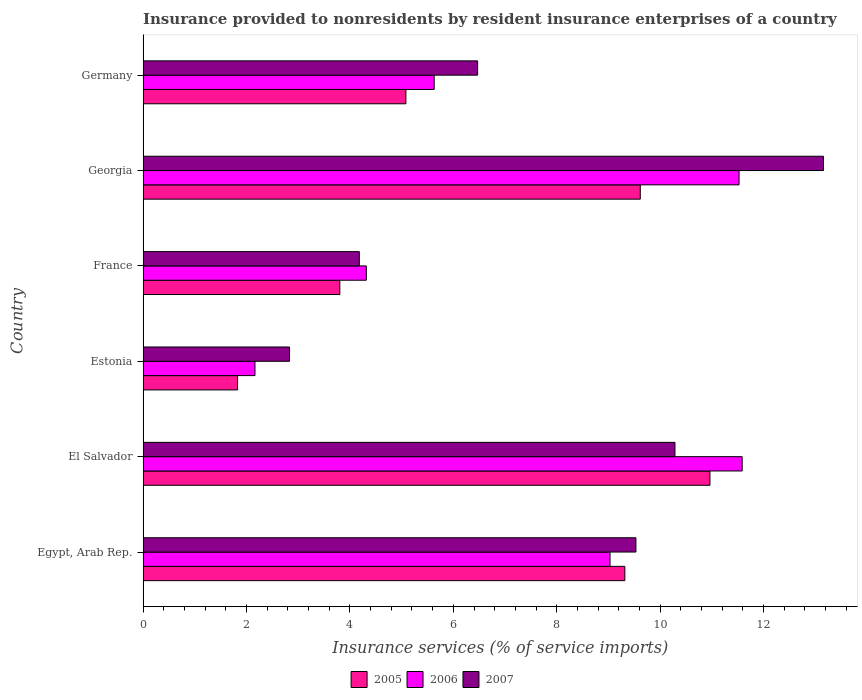Are the number of bars on each tick of the Y-axis equal?
Provide a short and direct response. Yes. How many bars are there on the 5th tick from the bottom?
Offer a terse response. 3. What is the label of the 6th group of bars from the top?
Provide a succinct answer. Egypt, Arab Rep. What is the insurance provided to nonresidents in 2005 in Germany?
Your answer should be compact. 5.08. Across all countries, what is the maximum insurance provided to nonresidents in 2006?
Offer a terse response. 11.59. Across all countries, what is the minimum insurance provided to nonresidents in 2007?
Ensure brevity in your answer.  2.83. In which country was the insurance provided to nonresidents in 2005 maximum?
Your answer should be very brief. El Salvador. In which country was the insurance provided to nonresidents in 2007 minimum?
Your response must be concise. Estonia. What is the total insurance provided to nonresidents in 2005 in the graph?
Provide a short and direct response. 40.61. What is the difference between the insurance provided to nonresidents in 2006 in Egypt, Arab Rep. and that in France?
Keep it short and to the point. 4.71. What is the difference between the insurance provided to nonresidents in 2005 in France and the insurance provided to nonresidents in 2006 in Georgia?
Provide a short and direct response. -7.72. What is the average insurance provided to nonresidents in 2005 per country?
Offer a terse response. 6.77. What is the difference between the insurance provided to nonresidents in 2005 and insurance provided to nonresidents in 2006 in Germany?
Offer a very short reply. -0.55. What is the ratio of the insurance provided to nonresidents in 2006 in Georgia to that in Germany?
Offer a very short reply. 2.05. Is the insurance provided to nonresidents in 2007 in Egypt, Arab Rep. less than that in France?
Offer a very short reply. No. Is the difference between the insurance provided to nonresidents in 2005 in El Salvador and France greater than the difference between the insurance provided to nonresidents in 2006 in El Salvador and France?
Make the answer very short. No. What is the difference between the highest and the second highest insurance provided to nonresidents in 2005?
Offer a terse response. 1.35. What is the difference between the highest and the lowest insurance provided to nonresidents in 2005?
Your answer should be very brief. 9.13. In how many countries, is the insurance provided to nonresidents in 2006 greater than the average insurance provided to nonresidents in 2006 taken over all countries?
Make the answer very short. 3. What does the 2nd bar from the top in Estonia represents?
Your response must be concise. 2006. What does the 1st bar from the bottom in Egypt, Arab Rep. represents?
Give a very brief answer. 2005. How many countries are there in the graph?
Provide a succinct answer. 6. What is the difference between two consecutive major ticks on the X-axis?
Give a very brief answer. 2. Does the graph contain any zero values?
Provide a short and direct response. No. How are the legend labels stacked?
Provide a succinct answer. Horizontal. What is the title of the graph?
Give a very brief answer. Insurance provided to nonresidents by resident insurance enterprises of a country. Does "2009" appear as one of the legend labels in the graph?
Offer a terse response. No. What is the label or title of the X-axis?
Give a very brief answer. Insurance services (% of service imports). What is the label or title of the Y-axis?
Your answer should be compact. Country. What is the Insurance services (% of service imports) of 2005 in Egypt, Arab Rep.?
Your answer should be compact. 9.32. What is the Insurance services (% of service imports) of 2006 in Egypt, Arab Rep.?
Offer a terse response. 9.03. What is the Insurance services (% of service imports) of 2007 in Egypt, Arab Rep.?
Your answer should be very brief. 9.53. What is the Insurance services (% of service imports) of 2005 in El Salvador?
Keep it short and to the point. 10.96. What is the Insurance services (% of service imports) in 2006 in El Salvador?
Ensure brevity in your answer.  11.59. What is the Insurance services (% of service imports) in 2007 in El Salvador?
Provide a succinct answer. 10.29. What is the Insurance services (% of service imports) of 2005 in Estonia?
Make the answer very short. 1.83. What is the Insurance services (% of service imports) in 2006 in Estonia?
Make the answer very short. 2.16. What is the Insurance services (% of service imports) of 2007 in Estonia?
Your answer should be very brief. 2.83. What is the Insurance services (% of service imports) of 2005 in France?
Your answer should be compact. 3.81. What is the Insurance services (% of service imports) in 2006 in France?
Make the answer very short. 4.32. What is the Insurance services (% of service imports) of 2007 in France?
Ensure brevity in your answer.  4.18. What is the Insurance services (% of service imports) in 2005 in Georgia?
Keep it short and to the point. 9.62. What is the Insurance services (% of service imports) in 2006 in Georgia?
Offer a terse response. 11.53. What is the Insurance services (% of service imports) of 2007 in Georgia?
Offer a very short reply. 13.16. What is the Insurance services (% of service imports) in 2005 in Germany?
Ensure brevity in your answer.  5.08. What is the Insurance services (% of service imports) of 2006 in Germany?
Your answer should be compact. 5.63. What is the Insurance services (% of service imports) of 2007 in Germany?
Your answer should be very brief. 6.47. Across all countries, what is the maximum Insurance services (% of service imports) of 2005?
Give a very brief answer. 10.96. Across all countries, what is the maximum Insurance services (% of service imports) in 2006?
Provide a short and direct response. 11.59. Across all countries, what is the maximum Insurance services (% of service imports) in 2007?
Provide a short and direct response. 13.16. Across all countries, what is the minimum Insurance services (% of service imports) in 2005?
Give a very brief answer. 1.83. Across all countries, what is the minimum Insurance services (% of service imports) in 2006?
Your answer should be compact. 2.16. Across all countries, what is the minimum Insurance services (% of service imports) of 2007?
Offer a very short reply. 2.83. What is the total Insurance services (% of service imports) in 2005 in the graph?
Make the answer very short. 40.61. What is the total Insurance services (% of service imports) in 2006 in the graph?
Offer a very short reply. 44.25. What is the total Insurance services (% of service imports) of 2007 in the graph?
Give a very brief answer. 46.46. What is the difference between the Insurance services (% of service imports) in 2005 in Egypt, Arab Rep. and that in El Salvador?
Make the answer very short. -1.65. What is the difference between the Insurance services (% of service imports) of 2006 in Egypt, Arab Rep. and that in El Salvador?
Offer a terse response. -2.56. What is the difference between the Insurance services (% of service imports) of 2007 in Egypt, Arab Rep. and that in El Salvador?
Provide a succinct answer. -0.75. What is the difference between the Insurance services (% of service imports) of 2005 in Egypt, Arab Rep. and that in Estonia?
Your answer should be compact. 7.49. What is the difference between the Insurance services (% of service imports) in 2006 in Egypt, Arab Rep. and that in Estonia?
Offer a terse response. 6.87. What is the difference between the Insurance services (% of service imports) in 2007 in Egypt, Arab Rep. and that in Estonia?
Provide a succinct answer. 6.7. What is the difference between the Insurance services (% of service imports) of 2005 in Egypt, Arab Rep. and that in France?
Your answer should be very brief. 5.51. What is the difference between the Insurance services (% of service imports) in 2006 in Egypt, Arab Rep. and that in France?
Keep it short and to the point. 4.71. What is the difference between the Insurance services (% of service imports) of 2007 in Egypt, Arab Rep. and that in France?
Your answer should be compact. 5.35. What is the difference between the Insurance services (% of service imports) of 2005 in Egypt, Arab Rep. and that in Georgia?
Offer a terse response. -0.3. What is the difference between the Insurance services (% of service imports) in 2006 in Egypt, Arab Rep. and that in Georgia?
Offer a very short reply. -2.5. What is the difference between the Insurance services (% of service imports) in 2007 in Egypt, Arab Rep. and that in Georgia?
Make the answer very short. -3.63. What is the difference between the Insurance services (% of service imports) in 2005 in Egypt, Arab Rep. and that in Germany?
Ensure brevity in your answer.  4.23. What is the difference between the Insurance services (% of service imports) in 2006 in Egypt, Arab Rep. and that in Germany?
Keep it short and to the point. 3.4. What is the difference between the Insurance services (% of service imports) of 2007 in Egypt, Arab Rep. and that in Germany?
Ensure brevity in your answer.  3.06. What is the difference between the Insurance services (% of service imports) in 2005 in El Salvador and that in Estonia?
Provide a succinct answer. 9.13. What is the difference between the Insurance services (% of service imports) of 2006 in El Salvador and that in Estonia?
Offer a very short reply. 9.42. What is the difference between the Insurance services (% of service imports) of 2007 in El Salvador and that in Estonia?
Your answer should be very brief. 7.45. What is the difference between the Insurance services (% of service imports) of 2005 in El Salvador and that in France?
Offer a very short reply. 7.16. What is the difference between the Insurance services (% of service imports) in 2006 in El Salvador and that in France?
Provide a succinct answer. 7.27. What is the difference between the Insurance services (% of service imports) of 2007 in El Salvador and that in France?
Your answer should be compact. 6.1. What is the difference between the Insurance services (% of service imports) of 2005 in El Salvador and that in Georgia?
Provide a short and direct response. 1.35. What is the difference between the Insurance services (% of service imports) of 2006 in El Salvador and that in Georgia?
Keep it short and to the point. 0.06. What is the difference between the Insurance services (% of service imports) in 2007 in El Salvador and that in Georgia?
Ensure brevity in your answer.  -2.87. What is the difference between the Insurance services (% of service imports) of 2005 in El Salvador and that in Germany?
Ensure brevity in your answer.  5.88. What is the difference between the Insurance services (% of service imports) in 2006 in El Salvador and that in Germany?
Keep it short and to the point. 5.96. What is the difference between the Insurance services (% of service imports) of 2007 in El Salvador and that in Germany?
Offer a very short reply. 3.82. What is the difference between the Insurance services (% of service imports) in 2005 in Estonia and that in France?
Your answer should be very brief. -1.98. What is the difference between the Insurance services (% of service imports) of 2006 in Estonia and that in France?
Your answer should be compact. -2.15. What is the difference between the Insurance services (% of service imports) of 2007 in Estonia and that in France?
Give a very brief answer. -1.35. What is the difference between the Insurance services (% of service imports) of 2005 in Estonia and that in Georgia?
Offer a very short reply. -7.79. What is the difference between the Insurance services (% of service imports) of 2006 in Estonia and that in Georgia?
Make the answer very short. -9.36. What is the difference between the Insurance services (% of service imports) in 2007 in Estonia and that in Georgia?
Keep it short and to the point. -10.32. What is the difference between the Insurance services (% of service imports) of 2005 in Estonia and that in Germany?
Your response must be concise. -3.25. What is the difference between the Insurance services (% of service imports) in 2006 in Estonia and that in Germany?
Provide a succinct answer. -3.47. What is the difference between the Insurance services (% of service imports) in 2007 in Estonia and that in Germany?
Give a very brief answer. -3.64. What is the difference between the Insurance services (% of service imports) in 2005 in France and that in Georgia?
Ensure brevity in your answer.  -5.81. What is the difference between the Insurance services (% of service imports) of 2006 in France and that in Georgia?
Offer a terse response. -7.21. What is the difference between the Insurance services (% of service imports) in 2007 in France and that in Georgia?
Your answer should be very brief. -8.98. What is the difference between the Insurance services (% of service imports) in 2005 in France and that in Germany?
Provide a succinct answer. -1.28. What is the difference between the Insurance services (% of service imports) in 2006 in France and that in Germany?
Your answer should be very brief. -1.31. What is the difference between the Insurance services (% of service imports) in 2007 in France and that in Germany?
Your answer should be very brief. -2.29. What is the difference between the Insurance services (% of service imports) in 2005 in Georgia and that in Germany?
Make the answer very short. 4.53. What is the difference between the Insurance services (% of service imports) in 2006 in Georgia and that in Germany?
Your answer should be very brief. 5.9. What is the difference between the Insurance services (% of service imports) in 2007 in Georgia and that in Germany?
Your answer should be compact. 6.69. What is the difference between the Insurance services (% of service imports) in 2005 in Egypt, Arab Rep. and the Insurance services (% of service imports) in 2006 in El Salvador?
Your answer should be very brief. -2.27. What is the difference between the Insurance services (% of service imports) in 2005 in Egypt, Arab Rep. and the Insurance services (% of service imports) in 2007 in El Salvador?
Provide a short and direct response. -0.97. What is the difference between the Insurance services (% of service imports) in 2006 in Egypt, Arab Rep. and the Insurance services (% of service imports) in 2007 in El Salvador?
Offer a terse response. -1.26. What is the difference between the Insurance services (% of service imports) in 2005 in Egypt, Arab Rep. and the Insurance services (% of service imports) in 2006 in Estonia?
Provide a succinct answer. 7.15. What is the difference between the Insurance services (% of service imports) in 2005 in Egypt, Arab Rep. and the Insurance services (% of service imports) in 2007 in Estonia?
Your answer should be compact. 6.48. What is the difference between the Insurance services (% of service imports) of 2006 in Egypt, Arab Rep. and the Insurance services (% of service imports) of 2007 in Estonia?
Make the answer very short. 6.2. What is the difference between the Insurance services (% of service imports) in 2005 in Egypt, Arab Rep. and the Insurance services (% of service imports) in 2006 in France?
Your response must be concise. 5. What is the difference between the Insurance services (% of service imports) in 2005 in Egypt, Arab Rep. and the Insurance services (% of service imports) in 2007 in France?
Your answer should be compact. 5.13. What is the difference between the Insurance services (% of service imports) in 2006 in Egypt, Arab Rep. and the Insurance services (% of service imports) in 2007 in France?
Offer a terse response. 4.85. What is the difference between the Insurance services (% of service imports) of 2005 in Egypt, Arab Rep. and the Insurance services (% of service imports) of 2006 in Georgia?
Give a very brief answer. -2.21. What is the difference between the Insurance services (% of service imports) of 2005 in Egypt, Arab Rep. and the Insurance services (% of service imports) of 2007 in Georgia?
Keep it short and to the point. -3.84. What is the difference between the Insurance services (% of service imports) of 2006 in Egypt, Arab Rep. and the Insurance services (% of service imports) of 2007 in Georgia?
Ensure brevity in your answer.  -4.13. What is the difference between the Insurance services (% of service imports) of 2005 in Egypt, Arab Rep. and the Insurance services (% of service imports) of 2006 in Germany?
Provide a succinct answer. 3.69. What is the difference between the Insurance services (% of service imports) in 2005 in Egypt, Arab Rep. and the Insurance services (% of service imports) in 2007 in Germany?
Keep it short and to the point. 2.85. What is the difference between the Insurance services (% of service imports) in 2006 in Egypt, Arab Rep. and the Insurance services (% of service imports) in 2007 in Germany?
Provide a succinct answer. 2.56. What is the difference between the Insurance services (% of service imports) of 2005 in El Salvador and the Insurance services (% of service imports) of 2006 in Estonia?
Give a very brief answer. 8.8. What is the difference between the Insurance services (% of service imports) of 2005 in El Salvador and the Insurance services (% of service imports) of 2007 in Estonia?
Offer a very short reply. 8.13. What is the difference between the Insurance services (% of service imports) in 2006 in El Salvador and the Insurance services (% of service imports) in 2007 in Estonia?
Offer a very short reply. 8.75. What is the difference between the Insurance services (% of service imports) of 2005 in El Salvador and the Insurance services (% of service imports) of 2006 in France?
Offer a very short reply. 6.64. What is the difference between the Insurance services (% of service imports) in 2005 in El Salvador and the Insurance services (% of service imports) in 2007 in France?
Make the answer very short. 6.78. What is the difference between the Insurance services (% of service imports) of 2006 in El Salvador and the Insurance services (% of service imports) of 2007 in France?
Make the answer very short. 7.4. What is the difference between the Insurance services (% of service imports) of 2005 in El Salvador and the Insurance services (% of service imports) of 2006 in Georgia?
Provide a succinct answer. -0.56. What is the difference between the Insurance services (% of service imports) of 2005 in El Salvador and the Insurance services (% of service imports) of 2007 in Georgia?
Make the answer very short. -2.2. What is the difference between the Insurance services (% of service imports) of 2006 in El Salvador and the Insurance services (% of service imports) of 2007 in Georgia?
Your response must be concise. -1.57. What is the difference between the Insurance services (% of service imports) of 2005 in El Salvador and the Insurance services (% of service imports) of 2006 in Germany?
Offer a very short reply. 5.33. What is the difference between the Insurance services (% of service imports) in 2005 in El Salvador and the Insurance services (% of service imports) in 2007 in Germany?
Give a very brief answer. 4.49. What is the difference between the Insurance services (% of service imports) in 2006 in El Salvador and the Insurance services (% of service imports) in 2007 in Germany?
Keep it short and to the point. 5.12. What is the difference between the Insurance services (% of service imports) of 2005 in Estonia and the Insurance services (% of service imports) of 2006 in France?
Your answer should be very brief. -2.49. What is the difference between the Insurance services (% of service imports) in 2005 in Estonia and the Insurance services (% of service imports) in 2007 in France?
Keep it short and to the point. -2.35. What is the difference between the Insurance services (% of service imports) of 2006 in Estonia and the Insurance services (% of service imports) of 2007 in France?
Make the answer very short. -2.02. What is the difference between the Insurance services (% of service imports) in 2005 in Estonia and the Insurance services (% of service imports) in 2006 in Georgia?
Give a very brief answer. -9.7. What is the difference between the Insurance services (% of service imports) of 2005 in Estonia and the Insurance services (% of service imports) of 2007 in Georgia?
Your response must be concise. -11.33. What is the difference between the Insurance services (% of service imports) in 2006 in Estonia and the Insurance services (% of service imports) in 2007 in Georgia?
Your answer should be compact. -10.99. What is the difference between the Insurance services (% of service imports) of 2005 in Estonia and the Insurance services (% of service imports) of 2006 in Germany?
Make the answer very short. -3.8. What is the difference between the Insurance services (% of service imports) in 2005 in Estonia and the Insurance services (% of service imports) in 2007 in Germany?
Offer a terse response. -4.64. What is the difference between the Insurance services (% of service imports) in 2006 in Estonia and the Insurance services (% of service imports) in 2007 in Germany?
Your answer should be compact. -4.31. What is the difference between the Insurance services (% of service imports) of 2005 in France and the Insurance services (% of service imports) of 2006 in Georgia?
Provide a succinct answer. -7.72. What is the difference between the Insurance services (% of service imports) of 2005 in France and the Insurance services (% of service imports) of 2007 in Georgia?
Your answer should be compact. -9.35. What is the difference between the Insurance services (% of service imports) of 2006 in France and the Insurance services (% of service imports) of 2007 in Georgia?
Keep it short and to the point. -8.84. What is the difference between the Insurance services (% of service imports) in 2005 in France and the Insurance services (% of service imports) in 2006 in Germany?
Ensure brevity in your answer.  -1.82. What is the difference between the Insurance services (% of service imports) in 2005 in France and the Insurance services (% of service imports) in 2007 in Germany?
Keep it short and to the point. -2.66. What is the difference between the Insurance services (% of service imports) in 2006 in France and the Insurance services (% of service imports) in 2007 in Germany?
Provide a short and direct response. -2.15. What is the difference between the Insurance services (% of service imports) of 2005 in Georgia and the Insurance services (% of service imports) of 2006 in Germany?
Provide a succinct answer. 3.99. What is the difference between the Insurance services (% of service imports) in 2005 in Georgia and the Insurance services (% of service imports) in 2007 in Germany?
Ensure brevity in your answer.  3.15. What is the difference between the Insurance services (% of service imports) in 2006 in Georgia and the Insurance services (% of service imports) in 2007 in Germany?
Make the answer very short. 5.06. What is the average Insurance services (% of service imports) in 2005 per country?
Your response must be concise. 6.77. What is the average Insurance services (% of service imports) in 2006 per country?
Provide a succinct answer. 7.38. What is the average Insurance services (% of service imports) in 2007 per country?
Offer a terse response. 7.74. What is the difference between the Insurance services (% of service imports) of 2005 and Insurance services (% of service imports) of 2006 in Egypt, Arab Rep.?
Your response must be concise. 0.29. What is the difference between the Insurance services (% of service imports) in 2005 and Insurance services (% of service imports) in 2007 in Egypt, Arab Rep.?
Provide a short and direct response. -0.21. What is the difference between the Insurance services (% of service imports) in 2006 and Insurance services (% of service imports) in 2007 in Egypt, Arab Rep.?
Make the answer very short. -0.5. What is the difference between the Insurance services (% of service imports) in 2005 and Insurance services (% of service imports) in 2006 in El Salvador?
Your answer should be very brief. -0.62. What is the difference between the Insurance services (% of service imports) in 2005 and Insurance services (% of service imports) in 2007 in El Salvador?
Your response must be concise. 0.68. What is the difference between the Insurance services (% of service imports) in 2006 and Insurance services (% of service imports) in 2007 in El Salvador?
Your response must be concise. 1.3. What is the difference between the Insurance services (% of service imports) in 2005 and Insurance services (% of service imports) in 2006 in Estonia?
Offer a terse response. -0.34. What is the difference between the Insurance services (% of service imports) of 2005 and Insurance services (% of service imports) of 2007 in Estonia?
Give a very brief answer. -1.01. What is the difference between the Insurance services (% of service imports) of 2006 and Insurance services (% of service imports) of 2007 in Estonia?
Provide a succinct answer. -0.67. What is the difference between the Insurance services (% of service imports) of 2005 and Insurance services (% of service imports) of 2006 in France?
Offer a very short reply. -0.51. What is the difference between the Insurance services (% of service imports) of 2005 and Insurance services (% of service imports) of 2007 in France?
Make the answer very short. -0.38. What is the difference between the Insurance services (% of service imports) in 2006 and Insurance services (% of service imports) in 2007 in France?
Offer a terse response. 0.14. What is the difference between the Insurance services (% of service imports) in 2005 and Insurance services (% of service imports) in 2006 in Georgia?
Offer a very short reply. -1.91. What is the difference between the Insurance services (% of service imports) of 2005 and Insurance services (% of service imports) of 2007 in Georgia?
Your answer should be very brief. -3.54. What is the difference between the Insurance services (% of service imports) of 2006 and Insurance services (% of service imports) of 2007 in Georgia?
Provide a succinct answer. -1.63. What is the difference between the Insurance services (% of service imports) in 2005 and Insurance services (% of service imports) in 2006 in Germany?
Make the answer very short. -0.55. What is the difference between the Insurance services (% of service imports) of 2005 and Insurance services (% of service imports) of 2007 in Germany?
Offer a very short reply. -1.39. What is the difference between the Insurance services (% of service imports) of 2006 and Insurance services (% of service imports) of 2007 in Germany?
Offer a terse response. -0.84. What is the ratio of the Insurance services (% of service imports) of 2005 in Egypt, Arab Rep. to that in El Salvador?
Your response must be concise. 0.85. What is the ratio of the Insurance services (% of service imports) in 2006 in Egypt, Arab Rep. to that in El Salvador?
Your answer should be compact. 0.78. What is the ratio of the Insurance services (% of service imports) of 2007 in Egypt, Arab Rep. to that in El Salvador?
Provide a short and direct response. 0.93. What is the ratio of the Insurance services (% of service imports) of 2005 in Egypt, Arab Rep. to that in Estonia?
Offer a terse response. 5.1. What is the ratio of the Insurance services (% of service imports) of 2006 in Egypt, Arab Rep. to that in Estonia?
Provide a succinct answer. 4.17. What is the ratio of the Insurance services (% of service imports) in 2007 in Egypt, Arab Rep. to that in Estonia?
Your response must be concise. 3.36. What is the ratio of the Insurance services (% of service imports) of 2005 in Egypt, Arab Rep. to that in France?
Give a very brief answer. 2.45. What is the ratio of the Insurance services (% of service imports) of 2006 in Egypt, Arab Rep. to that in France?
Ensure brevity in your answer.  2.09. What is the ratio of the Insurance services (% of service imports) of 2007 in Egypt, Arab Rep. to that in France?
Ensure brevity in your answer.  2.28. What is the ratio of the Insurance services (% of service imports) in 2006 in Egypt, Arab Rep. to that in Georgia?
Offer a very short reply. 0.78. What is the ratio of the Insurance services (% of service imports) in 2007 in Egypt, Arab Rep. to that in Georgia?
Your response must be concise. 0.72. What is the ratio of the Insurance services (% of service imports) in 2005 in Egypt, Arab Rep. to that in Germany?
Your answer should be compact. 1.83. What is the ratio of the Insurance services (% of service imports) of 2006 in Egypt, Arab Rep. to that in Germany?
Provide a short and direct response. 1.6. What is the ratio of the Insurance services (% of service imports) in 2007 in Egypt, Arab Rep. to that in Germany?
Give a very brief answer. 1.47. What is the ratio of the Insurance services (% of service imports) of 2005 in El Salvador to that in Estonia?
Offer a terse response. 6. What is the ratio of the Insurance services (% of service imports) of 2006 in El Salvador to that in Estonia?
Provide a short and direct response. 5.35. What is the ratio of the Insurance services (% of service imports) of 2007 in El Salvador to that in Estonia?
Provide a succinct answer. 3.63. What is the ratio of the Insurance services (% of service imports) of 2005 in El Salvador to that in France?
Keep it short and to the point. 2.88. What is the ratio of the Insurance services (% of service imports) of 2006 in El Salvador to that in France?
Ensure brevity in your answer.  2.68. What is the ratio of the Insurance services (% of service imports) of 2007 in El Salvador to that in France?
Keep it short and to the point. 2.46. What is the ratio of the Insurance services (% of service imports) of 2005 in El Salvador to that in Georgia?
Offer a very short reply. 1.14. What is the ratio of the Insurance services (% of service imports) of 2006 in El Salvador to that in Georgia?
Offer a terse response. 1.01. What is the ratio of the Insurance services (% of service imports) in 2007 in El Salvador to that in Georgia?
Your response must be concise. 0.78. What is the ratio of the Insurance services (% of service imports) in 2005 in El Salvador to that in Germany?
Provide a succinct answer. 2.16. What is the ratio of the Insurance services (% of service imports) in 2006 in El Salvador to that in Germany?
Your response must be concise. 2.06. What is the ratio of the Insurance services (% of service imports) in 2007 in El Salvador to that in Germany?
Give a very brief answer. 1.59. What is the ratio of the Insurance services (% of service imports) in 2005 in Estonia to that in France?
Keep it short and to the point. 0.48. What is the ratio of the Insurance services (% of service imports) of 2006 in Estonia to that in France?
Your answer should be compact. 0.5. What is the ratio of the Insurance services (% of service imports) of 2007 in Estonia to that in France?
Your answer should be compact. 0.68. What is the ratio of the Insurance services (% of service imports) of 2005 in Estonia to that in Georgia?
Your answer should be very brief. 0.19. What is the ratio of the Insurance services (% of service imports) in 2006 in Estonia to that in Georgia?
Ensure brevity in your answer.  0.19. What is the ratio of the Insurance services (% of service imports) in 2007 in Estonia to that in Georgia?
Give a very brief answer. 0.22. What is the ratio of the Insurance services (% of service imports) of 2005 in Estonia to that in Germany?
Keep it short and to the point. 0.36. What is the ratio of the Insurance services (% of service imports) in 2006 in Estonia to that in Germany?
Offer a terse response. 0.38. What is the ratio of the Insurance services (% of service imports) of 2007 in Estonia to that in Germany?
Make the answer very short. 0.44. What is the ratio of the Insurance services (% of service imports) of 2005 in France to that in Georgia?
Offer a terse response. 0.4. What is the ratio of the Insurance services (% of service imports) in 2006 in France to that in Georgia?
Your answer should be compact. 0.37. What is the ratio of the Insurance services (% of service imports) of 2007 in France to that in Georgia?
Offer a terse response. 0.32. What is the ratio of the Insurance services (% of service imports) of 2005 in France to that in Germany?
Provide a succinct answer. 0.75. What is the ratio of the Insurance services (% of service imports) of 2006 in France to that in Germany?
Your answer should be compact. 0.77. What is the ratio of the Insurance services (% of service imports) of 2007 in France to that in Germany?
Offer a very short reply. 0.65. What is the ratio of the Insurance services (% of service imports) of 2005 in Georgia to that in Germany?
Provide a succinct answer. 1.89. What is the ratio of the Insurance services (% of service imports) of 2006 in Georgia to that in Germany?
Provide a succinct answer. 2.05. What is the ratio of the Insurance services (% of service imports) in 2007 in Georgia to that in Germany?
Your answer should be very brief. 2.03. What is the difference between the highest and the second highest Insurance services (% of service imports) of 2005?
Provide a succinct answer. 1.35. What is the difference between the highest and the second highest Insurance services (% of service imports) of 2006?
Keep it short and to the point. 0.06. What is the difference between the highest and the second highest Insurance services (% of service imports) in 2007?
Ensure brevity in your answer.  2.87. What is the difference between the highest and the lowest Insurance services (% of service imports) of 2005?
Your response must be concise. 9.13. What is the difference between the highest and the lowest Insurance services (% of service imports) in 2006?
Your answer should be very brief. 9.42. What is the difference between the highest and the lowest Insurance services (% of service imports) in 2007?
Provide a succinct answer. 10.32. 